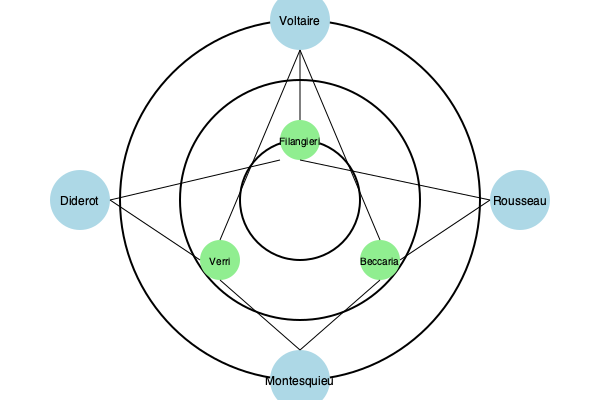Analyze the network diagram depicting the influence of Enlightenment thinkers on Mediterranean intellectual circles. Which Enlightenment philosopher appears to have had the most direct connections to Mediterranean intellectuals, and what does this suggest about the transmission of Enlightenment ideas in the region? To answer this question, we need to examine the network diagram and follow these steps:

1. Identify the Enlightenment thinkers:
   - Voltaire (top)
   - Rousseau (right)
   - Montesquieu (bottom)
   - Diderot (left)

2. Identify the Mediterranean intellectuals:
   - Filangieri (inner circle, top)
   - Beccaria (inner circle, right)
   - Verri (inner circle, left)

3. Count the connections between each Enlightenment thinker and the Mediterranean intellectuals:
   - Voltaire: 3 connections (to Filangieri, Beccaria, and Verri)
   - Rousseau: 2 connections (to Filangieri and Beccaria)
   - Montesquieu: 2 connections (to Beccaria and Verri)
   - Diderot: 2 connections (to Filangieri and Verri)

4. Determine the Enlightenment thinker with the most connections:
   Voltaire has the most direct connections (3) to Mediterranean intellectuals.

5. Interpret the significance:
   Voltaire's prominence in the network suggests that his ideas were particularly influential in Mediterranean intellectual circles. This could indicate that:
   a) Voltaire's works were more widely translated or circulated in the region.
   b) His ideas resonated more strongly with Mediterranean thinkers.
   c) He may have had more personal connections or correspondence with intellectuals in the area.

6. Consider the implications for the transmission of Enlightenment ideas:
   The diverse connections shown in the diagram imply that Enlightenment ideas spread through multiple channels and thinkers, with Voltaire playing a central role. This suggests a complex and multifaceted transmission of Enlightenment thought in the Mediterranean region, rather than a single dominant influence.
Answer: Voltaire; indicates widespread circulation and resonance of his ideas in Mediterranean intellectual circles. 